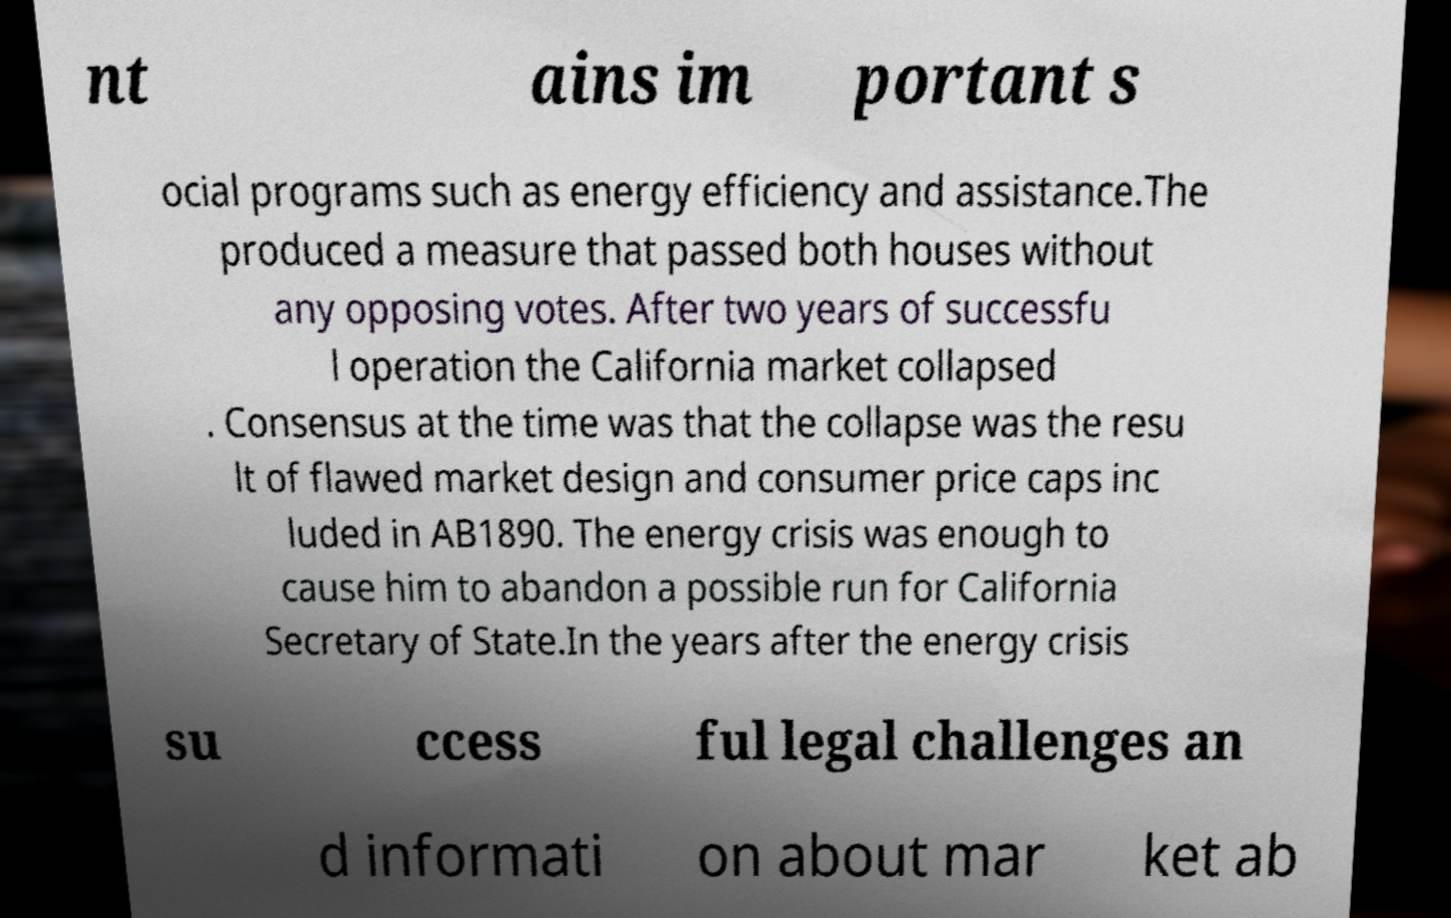Can you read and provide the text displayed in the image?This photo seems to have some interesting text. Can you extract and type it out for me? nt ains im portant s ocial programs such as energy efficiency and assistance.The produced a measure that passed both houses without any opposing votes. After two years of successfu l operation the California market collapsed . Consensus at the time was that the collapse was the resu lt of flawed market design and consumer price caps inc luded in AB1890. The energy crisis was enough to cause him to abandon a possible run for California Secretary of State.In the years after the energy crisis su ccess ful legal challenges an d informati on about mar ket ab 